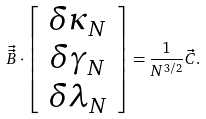Convert formula to latex. <formula><loc_0><loc_0><loc_500><loc_500>\vec { \vec { B } } \cdot \left [ \begin{array} { c } \delta \kappa _ { N } \\ \delta \gamma _ { N } \\ \delta \lambda _ { N } \end{array} \right ] = \frac { 1 } { N ^ { 3 / 2 } } \vec { C } .</formula> 